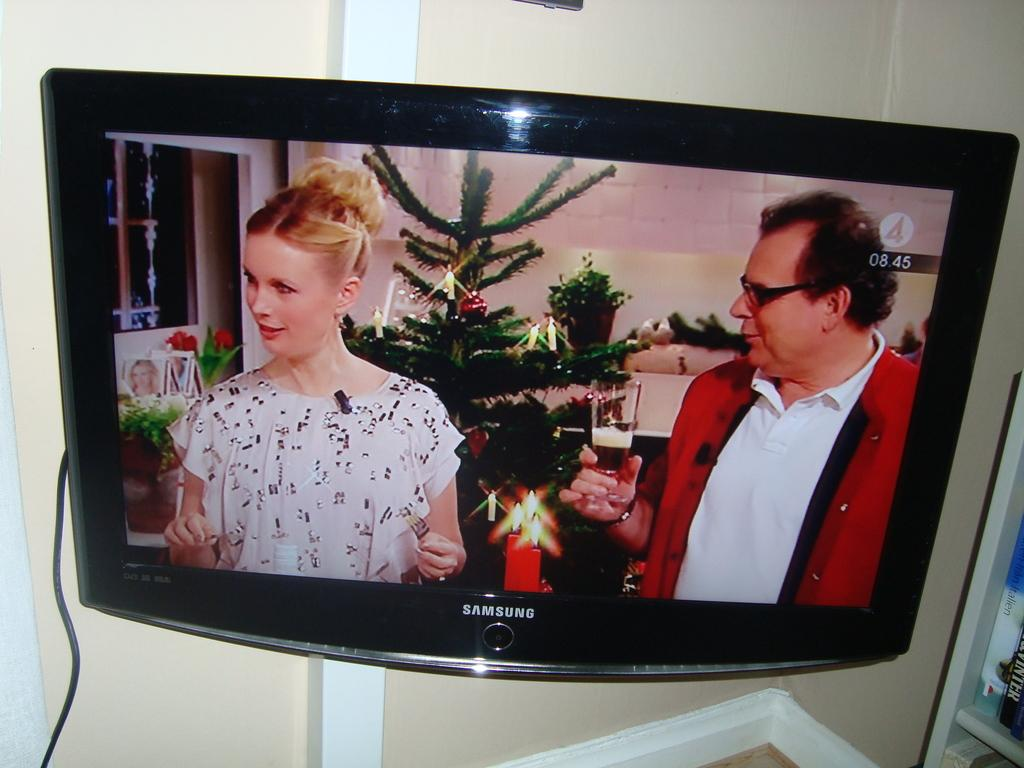<image>
Summarize the visual content of the image. A Samsung monitor shows two people standing in front of a Christmas tree. 